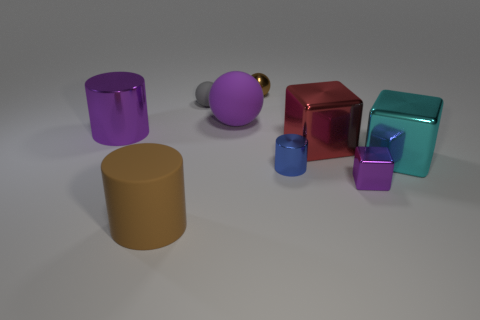Subtract all matte spheres. How many spheres are left? 1 Subtract 1 blocks. How many blocks are left? 2 Subtract all gray spheres. How many spheres are left? 2 Subtract all cyan spheres. Subtract all yellow cylinders. How many spheres are left? 3 Subtract all spheres. How many objects are left? 6 Subtract all gray rubber spheres. Subtract all tiny metallic cubes. How many objects are left? 7 Add 1 purple shiny cylinders. How many purple shiny cylinders are left? 2 Add 5 small metallic cylinders. How many small metallic cylinders exist? 6 Subtract 0 green spheres. How many objects are left? 9 